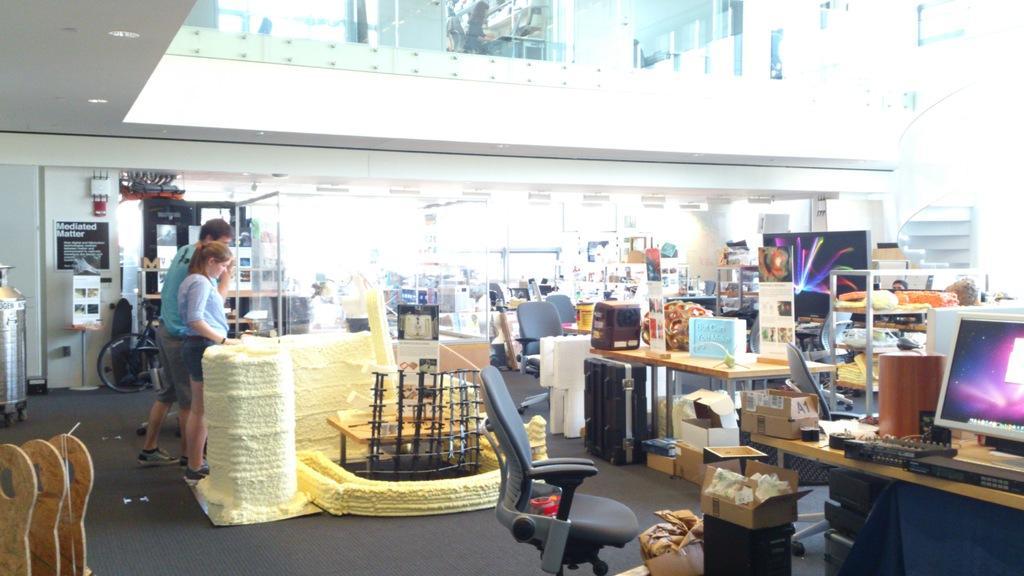Could you give a brief overview of what you see in this image? This picture shows the inner view of a building. There are glass doors, one staircase, some different objects are on the surface, so many lights attached to the ceiling, one pole with board, one carpet on the floor, one poster and some objects are attached to the wall. There are some chairs, one object on the chair, some tables, so many objects are on the table, one computer on the table and some persons in the room. 